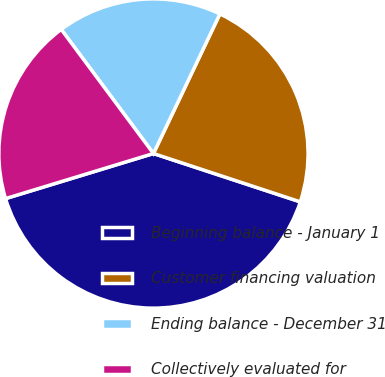Convert chart. <chart><loc_0><loc_0><loc_500><loc_500><pie_chart><fcel>Beginning balance - January 1<fcel>Customer financing valuation<fcel>Ending balance - December 31<fcel>Collectively evaluated for<nl><fcel>40.23%<fcel>22.99%<fcel>17.24%<fcel>19.54%<nl></chart> 